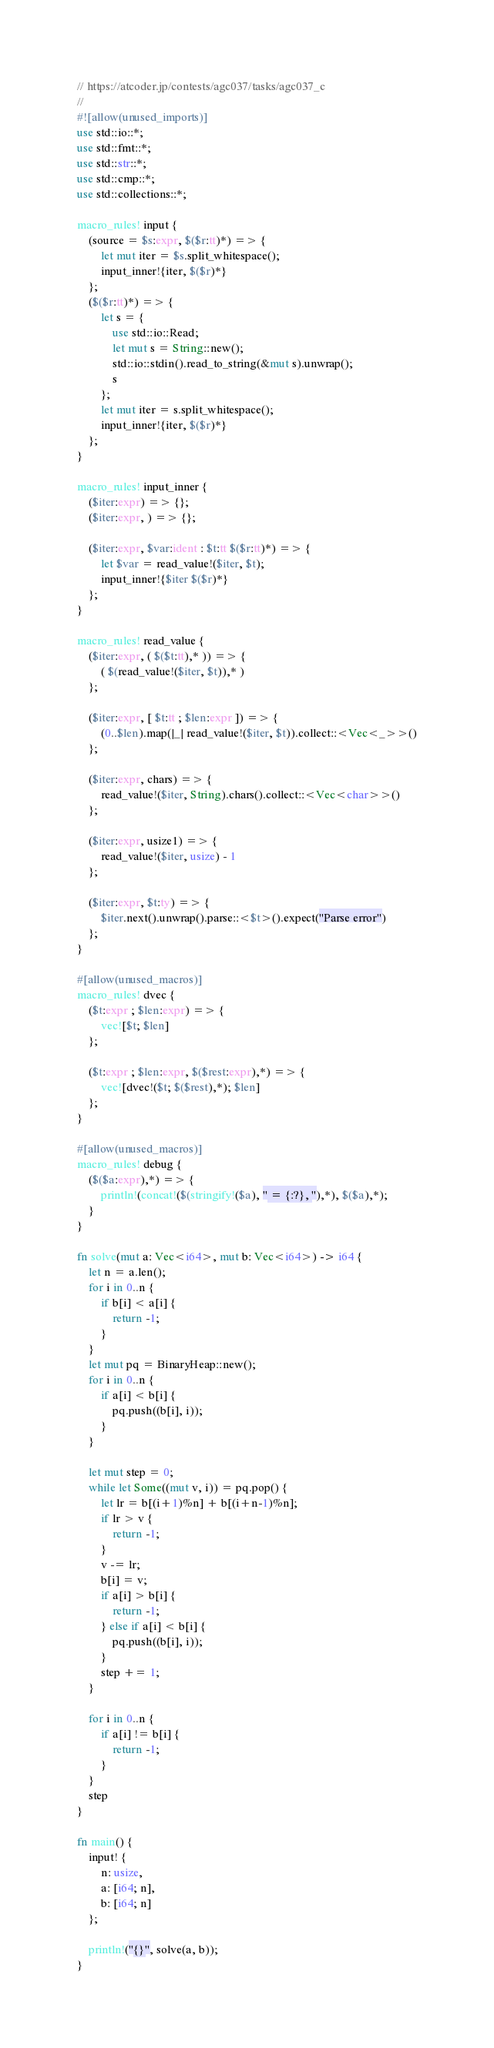Convert code to text. <code><loc_0><loc_0><loc_500><loc_500><_Rust_>// https://atcoder.jp/contests/agc037/tasks/agc037_c
//
#![allow(unused_imports)]
use std::io::*;
use std::fmt::*;
use std::str::*;
use std::cmp::*;
use std::collections::*;

macro_rules! input {
    (source = $s:expr, $($r:tt)*) => {
        let mut iter = $s.split_whitespace();
        input_inner!{iter, $($r)*}
    };
    ($($r:tt)*) => {
        let s = {
            use std::io::Read;
            let mut s = String::new();
            std::io::stdin().read_to_string(&mut s).unwrap();
            s
        };
        let mut iter = s.split_whitespace();
        input_inner!{iter, $($r)*}
    };
}

macro_rules! input_inner {
    ($iter:expr) => {};
    ($iter:expr, ) => {};

    ($iter:expr, $var:ident : $t:tt $($r:tt)*) => {
        let $var = read_value!($iter, $t);
        input_inner!{$iter $($r)*}
    };
}

macro_rules! read_value {
    ($iter:expr, ( $($t:tt),* )) => {
        ( $(read_value!($iter, $t)),* )
    };

    ($iter:expr, [ $t:tt ; $len:expr ]) => {
        (0..$len).map(|_| read_value!($iter, $t)).collect::<Vec<_>>()
    };

    ($iter:expr, chars) => {
        read_value!($iter, String).chars().collect::<Vec<char>>()
    };

    ($iter:expr, usize1) => {
        read_value!($iter, usize) - 1
    };

    ($iter:expr, $t:ty) => {
        $iter.next().unwrap().parse::<$t>().expect("Parse error")
    };
}

#[allow(unused_macros)]
macro_rules! dvec {
    ($t:expr ; $len:expr) => {
        vec![$t; $len]
    };

    ($t:expr ; $len:expr, $($rest:expr),*) => {
        vec![dvec!($t; $($rest),*); $len]
    };
}

#[allow(unused_macros)]
macro_rules! debug {
    ($($a:expr),*) => {
        println!(concat!($(stringify!($a), " = {:?}, "),*), $($a),*);
    }
}

fn solve(mut a: Vec<i64>, mut b: Vec<i64>) -> i64 {
    let n = a.len();
    for i in 0..n {
        if b[i] < a[i] {
            return -1;
        }
    }
    let mut pq = BinaryHeap::new();
    for i in 0..n {
        if a[i] < b[i] {
            pq.push((b[i], i));
        }
    }

    let mut step = 0;
    while let Some((mut v, i)) = pq.pop() {
        let lr = b[(i+1)%n] + b[(i+n-1)%n];
        if lr > v {
            return -1;
        }
        v -= lr;
        b[i] = v;
        if a[i] > b[i] {
            return -1;
        } else if a[i] < b[i] {
            pq.push((b[i], i));
        }
        step += 1;
    }

    for i in 0..n {
        if a[i] != b[i] {
            return -1;
        }
    }
    step
}

fn main() {
    input! {
        n: usize,
        a: [i64; n],
        b: [i64; n]
    };

    println!("{}", solve(a, b));
}
</code> 